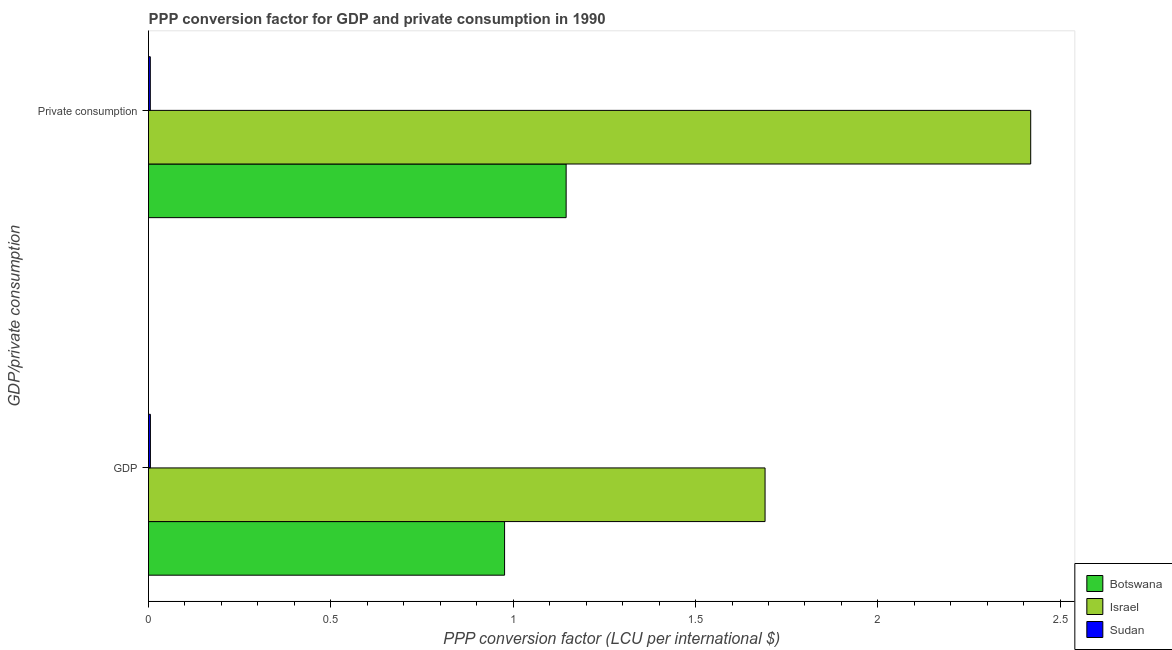How many different coloured bars are there?
Your answer should be very brief. 3. How many groups of bars are there?
Keep it short and to the point. 2. Are the number of bars per tick equal to the number of legend labels?
Provide a short and direct response. Yes. How many bars are there on the 2nd tick from the bottom?
Your response must be concise. 3. What is the label of the 2nd group of bars from the top?
Give a very brief answer. GDP. What is the ppp conversion factor for private consumption in Botswana?
Provide a succinct answer. 1.15. Across all countries, what is the maximum ppp conversion factor for gdp?
Offer a terse response. 1.69. Across all countries, what is the minimum ppp conversion factor for private consumption?
Your answer should be compact. 0. In which country was the ppp conversion factor for gdp maximum?
Offer a very short reply. Israel. In which country was the ppp conversion factor for private consumption minimum?
Provide a succinct answer. Sudan. What is the total ppp conversion factor for private consumption in the graph?
Offer a very short reply. 3.57. What is the difference between the ppp conversion factor for private consumption in Botswana and that in Israel?
Give a very brief answer. -1.27. What is the difference between the ppp conversion factor for private consumption in Sudan and the ppp conversion factor for gdp in Israel?
Your response must be concise. -1.69. What is the average ppp conversion factor for private consumption per country?
Keep it short and to the point. 1.19. What is the difference between the ppp conversion factor for gdp and ppp conversion factor for private consumption in Botswana?
Offer a terse response. -0.17. In how many countries, is the ppp conversion factor for private consumption greater than 2 LCU?
Offer a terse response. 1. What is the ratio of the ppp conversion factor for gdp in Israel to that in Botswana?
Your answer should be very brief. 1.73. Is the ppp conversion factor for gdp in Botswana less than that in Sudan?
Give a very brief answer. No. What does the 3rd bar from the top in GDP represents?
Offer a terse response. Botswana. What does the 1st bar from the bottom in GDP represents?
Provide a short and direct response. Botswana. How many bars are there?
Your answer should be compact. 6. Are all the bars in the graph horizontal?
Your response must be concise. Yes. What is the difference between two consecutive major ticks on the X-axis?
Make the answer very short. 0.5. Where does the legend appear in the graph?
Provide a succinct answer. Bottom right. How are the legend labels stacked?
Provide a succinct answer. Vertical. What is the title of the graph?
Make the answer very short. PPP conversion factor for GDP and private consumption in 1990. Does "Marshall Islands" appear as one of the legend labels in the graph?
Your answer should be compact. No. What is the label or title of the X-axis?
Your answer should be compact. PPP conversion factor (LCU per international $). What is the label or title of the Y-axis?
Give a very brief answer. GDP/private consumption. What is the PPP conversion factor (LCU per international $) in Botswana in GDP?
Your answer should be very brief. 0.98. What is the PPP conversion factor (LCU per international $) in Israel in GDP?
Give a very brief answer. 1.69. What is the PPP conversion factor (LCU per international $) of Sudan in GDP?
Offer a terse response. 0.01. What is the PPP conversion factor (LCU per international $) of Botswana in  Private consumption?
Keep it short and to the point. 1.15. What is the PPP conversion factor (LCU per international $) in Israel in  Private consumption?
Keep it short and to the point. 2.42. What is the PPP conversion factor (LCU per international $) of Sudan in  Private consumption?
Offer a very short reply. 0. Across all GDP/private consumption, what is the maximum PPP conversion factor (LCU per international $) in Botswana?
Give a very brief answer. 1.15. Across all GDP/private consumption, what is the maximum PPP conversion factor (LCU per international $) of Israel?
Give a very brief answer. 2.42. Across all GDP/private consumption, what is the maximum PPP conversion factor (LCU per international $) of Sudan?
Your answer should be compact. 0.01. Across all GDP/private consumption, what is the minimum PPP conversion factor (LCU per international $) in Botswana?
Offer a very short reply. 0.98. Across all GDP/private consumption, what is the minimum PPP conversion factor (LCU per international $) of Israel?
Give a very brief answer. 1.69. Across all GDP/private consumption, what is the minimum PPP conversion factor (LCU per international $) of Sudan?
Ensure brevity in your answer.  0. What is the total PPP conversion factor (LCU per international $) in Botswana in the graph?
Ensure brevity in your answer.  2.12. What is the total PPP conversion factor (LCU per international $) in Israel in the graph?
Offer a terse response. 4.11. What is the total PPP conversion factor (LCU per international $) of Sudan in the graph?
Your answer should be compact. 0.01. What is the difference between the PPP conversion factor (LCU per international $) of Botswana in GDP and that in  Private consumption?
Provide a short and direct response. -0.17. What is the difference between the PPP conversion factor (LCU per international $) in Israel in GDP and that in  Private consumption?
Provide a succinct answer. -0.73. What is the difference between the PPP conversion factor (LCU per international $) of Botswana in GDP and the PPP conversion factor (LCU per international $) of Israel in  Private consumption?
Ensure brevity in your answer.  -1.44. What is the difference between the PPP conversion factor (LCU per international $) in Botswana in GDP and the PPP conversion factor (LCU per international $) in Sudan in  Private consumption?
Keep it short and to the point. 0.97. What is the difference between the PPP conversion factor (LCU per international $) in Israel in GDP and the PPP conversion factor (LCU per international $) in Sudan in  Private consumption?
Your answer should be very brief. 1.69. What is the average PPP conversion factor (LCU per international $) of Botswana per GDP/private consumption?
Ensure brevity in your answer.  1.06. What is the average PPP conversion factor (LCU per international $) of Israel per GDP/private consumption?
Your answer should be very brief. 2.05. What is the average PPP conversion factor (LCU per international $) of Sudan per GDP/private consumption?
Keep it short and to the point. 0.01. What is the difference between the PPP conversion factor (LCU per international $) of Botswana and PPP conversion factor (LCU per international $) of Israel in GDP?
Your answer should be compact. -0.71. What is the difference between the PPP conversion factor (LCU per international $) of Botswana and PPP conversion factor (LCU per international $) of Sudan in GDP?
Provide a succinct answer. 0.97. What is the difference between the PPP conversion factor (LCU per international $) of Israel and PPP conversion factor (LCU per international $) of Sudan in GDP?
Give a very brief answer. 1.69. What is the difference between the PPP conversion factor (LCU per international $) in Botswana and PPP conversion factor (LCU per international $) in Israel in  Private consumption?
Ensure brevity in your answer.  -1.27. What is the difference between the PPP conversion factor (LCU per international $) of Botswana and PPP conversion factor (LCU per international $) of Sudan in  Private consumption?
Make the answer very short. 1.14. What is the difference between the PPP conversion factor (LCU per international $) in Israel and PPP conversion factor (LCU per international $) in Sudan in  Private consumption?
Offer a terse response. 2.41. What is the ratio of the PPP conversion factor (LCU per international $) of Botswana in GDP to that in  Private consumption?
Provide a short and direct response. 0.85. What is the ratio of the PPP conversion factor (LCU per international $) in Israel in GDP to that in  Private consumption?
Keep it short and to the point. 0.7. What is the ratio of the PPP conversion factor (LCU per international $) of Sudan in GDP to that in  Private consumption?
Make the answer very short. 1.06. What is the difference between the highest and the second highest PPP conversion factor (LCU per international $) in Botswana?
Offer a very short reply. 0.17. What is the difference between the highest and the second highest PPP conversion factor (LCU per international $) of Israel?
Give a very brief answer. 0.73. What is the difference between the highest and the second highest PPP conversion factor (LCU per international $) of Sudan?
Your answer should be compact. 0. What is the difference between the highest and the lowest PPP conversion factor (LCU per international $) of Botswana?
Your answer should be compact. 0.17. What is the difference between the highest and the lowest PPP conversion factor (LCU per international $) in Israel?
Ensure brevity in your answer.  0.73. 